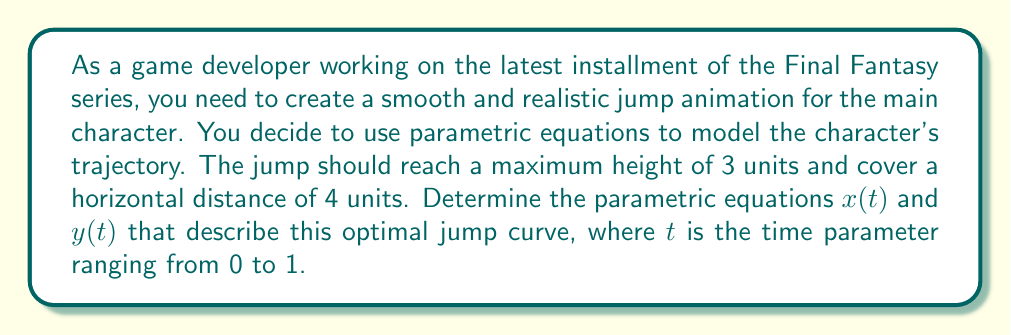Could you help me with this problem? To solve this problem, we'll follow these steps:

1) For a smooth jump animation, we can use a parabolic trajectory. The general form of a parabola in parametric equations is:

   $x(t) = at$
   $y(t) = bt(1-t)$

   Where $a$ and $b$ are constants we need to determine.

2) We know the horizontal distance covered is 4 units when $t = 1$:

   $x(1) = a(1) = 4$
   Therefore, $a = 4$

3) The maximum height occurs at $t = 0.5$ (midpoint of the jump) and should be 3 units:

   $y(0.5) = b(0.5)(1-0.5) = 3$
   $0.25b = 3$
   $b = 12$

4) Now we have our parametric equations:

   $x(t) = 4t$
   $y(t) = 12t(1-t)$

5) Let's verify:
   - At $t = 0$: $x(0) = 0$, $y(0) = 0$ (starting point)
   - At $t = 0.5$: $x(0.5) = 2$, $y(0.5) = 3$ (middle of jump, maximum height)
   - At $t = 1$: $x(1) = 4$, $y(1) = 0$ (ending point)

These equations will create a smooth, parabolic jump animation that meets the specified requirements.
Answer: The optimal parametric equations for the character's jump animation are:

$x(t) = 4t$
$y(t) = 12t(1-t)$

Where $t$ is the time parameter ranging from 0 to 1. 